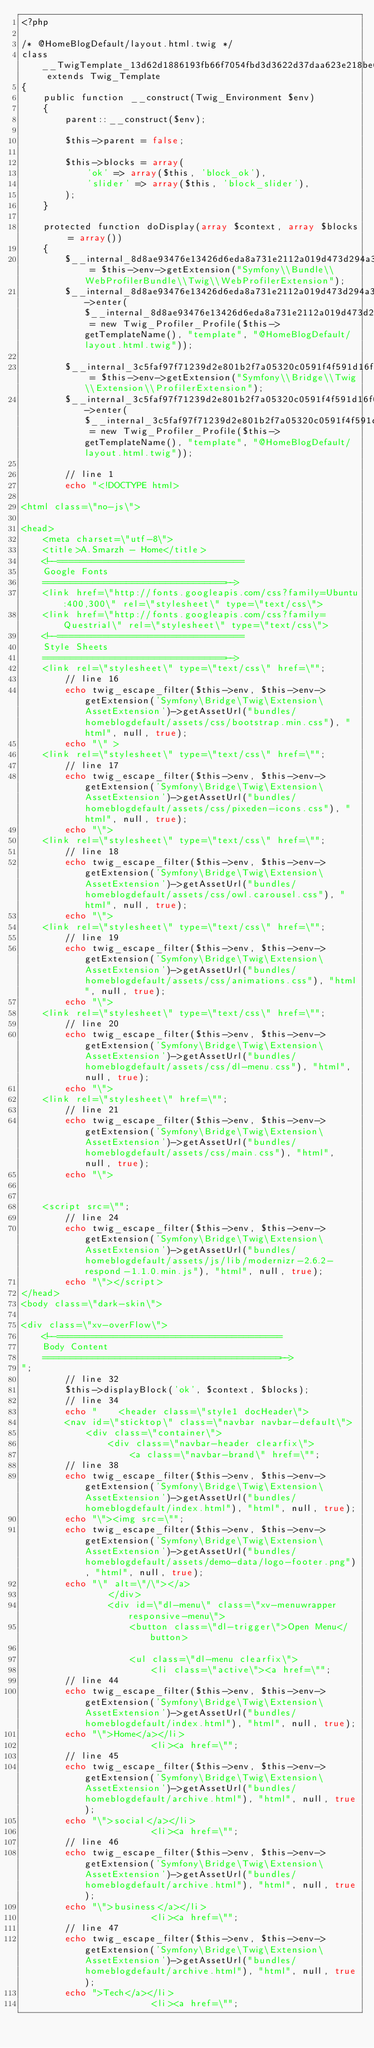Convert code to text. <code><loc_0><loc_0><loc_500><loc_500><_PHP_><?php

/* @HomeBlogDefault/layout.html.twig */
class __TwigTemplate_13d62d1886193fb66f7054fbd3d3622d37daa623e218be66a646269028b3d890 extends Twig_Template
{
    public function __construct(Twig_Environment $env)
    {
        parent::__construct($env);

        $this->parent = false;

        $this->blocks = array(
            'ok' => array($this, 'block_ok'),
            'slider' => array($this, 'block_slider'),
        );
    }

    protected function doDisplay(array $context, array $blocks = array())
    {
        $__internal_8d8ae93476e13426d6eda8a731e2112a019d473d294a39c8b48ecb1a699f4684 = $this->env->getExtension("Symfony\\Bundle\\WebProfilerBundle\\Twig\\WebProfilerExtension");
        $__internal_8d8ae93476e13426d6eda8a731e2112a019d473d294a39c8b48ecb1a699f4684->enter($__internal_8d8ae93476e13426d6eda8a731e2112a019d473d294a39c8b48ecb1a699f4684_prof = new Twig_Profiler_Profile($this->getTemplateName(), "template", "@HomeBlogDefault/layout.html.twig"));

        $__internal_3c5faf97f71239d2e801b2f7a05320c0591f4f591d16f0070a4f111e7c85e779 = $this->env->getExtension("Symfony\\Bridge\\Twig\\Extension\\ProfilerExtension");
        $__internal_3c5faf97f71239d2e801b2f7a05320c0591f4f591d16f0070a4f111e7c85e779->enter($__internal_3c5faf97f71239d2e801b2f7a05320c0591f4f591d16f0070a4f111e7c85e779_prof = new Twig_Profiler_Profile($this->getTemplateName(), "template", "@HomeBlogDefault/layout.html.twig"));

        // line 1
        echo "<!DOCTYPE html>

<html class=\"no-js\">

<head>
    <meta charset=\"utf-8\">
    <title>A.Smarzh - Home</title>
    <!--=================================
    Google Fonts
    =================================-->
    <link href=\"http://fonts.googleapis.com/css?family=Ubuntu:400,300\" rel=\"stylesheet\" type=\"text/css\">
    <link href=\"http://fonts.googleapis.com/css?family=Questrial\" rel=\"stylesheet\" type=\"text/css\">
    <!--=================================
    Style Sheets
    =================================-->
    <link rel=\"stylesheet\" type=\"text/css\" href=\"";
        // line 16
        echo twig_escape_filter($this->env, $this->env->getExtension('Symfony\Bridge\Twig\Extension\AssetExtension')->getAssetUrl("bundles/homeblogdefault/assets/css/bootstrap.min.css"), "html", null, true);
        echo "\" >
    <link rel=\"stylesheet\" type=\"text/css\" href=\"";
        // line 17
        echo twig_escape_filter($this->env, $this->env->getExtension('Symfony\Bridge\Twig\Extension\AssetExtension')->getAssetUrl("bundles/homeblogdefault/assets/css/pixeden-icons.css"), "html", null, true);
        echo "\">
    <link rel=\"stylesheet\" type=\"text/css\" href=\"";
        // line 18
        echo twig_escape_filter($this->env, $this->env->getExtension('Symfony\Bridge\Twig\Extension\AssetExtension')->getAssetUrl("bundles/homeblogdefault/assets/css/owl.carousel.css"), "html", null, true);
        echo "\">
    <link rel=\"stylesheet\" type=\"text/css\" href=\"";
        // line 19
        echo twig_escape_filter($this->env, $this->env->getExtension('Symfony\Bridge\Twig\Extension\AssetExtension')->getAssetUrl("bundles/homeblogdefault/assets/css/animations.css"), "html", null, true);
        echo "\">
    <link rel=\"stylesheet\" type=\"text/css\" href=\"";
        // line 20
        echo twig_escape_filter($this->env, $this->env->getExtension('Symfony\Bridge\Twig\Extension\AssetExtension')->getAssetUrl("bundles/homeblogdefault/assets/css/dl-menu.css"), "html", null, true);
        echo "\">
    <link rel=\"stylesheet\" href=\"";
        // line 21
        echo twig_escape_filter($this->env, $this->env->getExtension('Symfony\Bridge\Twig\Extension\AssetExtension')->getAssetUrl("bundles/homeblogdefault/assets/css/main.css"), "html", null, true);
        echo "\">


    <script src=\"";
        // line 24
        echo twig_escape_filter($this->env, $this->env->getExtension('Symfony\Bridge\Twig\Extension\AssetExtension')->getAssetUrl("bundles/homeblogdefault/assets/js/lib/modernizr-2.6.2-respond-1.1.0.min.js"), "html", null, true);
        echo "\"></script>
</head>
<body class=\"dark-skin\">

<div class=\"xv-overFlow\">
    <!--========================================
    Body Content
    ===========================================-->
";
        // line 32
        $this->displayBlock('ok', $context, $blocks);
        // line 34
        echo "    <header class=\"style1 docHeader\">
        <nav id=\"sticktop\" class=\"navbar navbar-default\">
            <div class=\"container\">
                <div class=\"navbar-header clearfix\">
                    <a class=\"navbar-brand\" href=\"";
        // line 38
        echo twig_escape_filter($this->env, $this->env->getExtension('Symfony\Bridge\Twig\Extension\AssetExtension')->getAssetUrl("bundles/homeblogdefault/index.html"), "html", null, true);
        echo "\"><img src=\"";
        echo twig_escape_filter($this->env, $this->env->getExtension('Symfony\Bridge\Twig\Extension\AssetExtension')->getAssetUrl("bundles/homeblogdefault/assets/demo-data/logo-footer.png"), "html", null, true);
        echo "\" alt=\"/\"></a>
                </div>
                <div id=\"dl-menu\" class=\"xv-menuwrapper responsive-menu\">
                    <button class=\"dl-trigger\">Open Menu</button>

                    <ul class=\"dl-menu clearfix\">
                        <li class=\"active\"><a href=\"";
        // line 44
        echo twig_escape_filter($this->env, $this->env->getExtension('Symfony\Bridge\Twig\Extension\AssetExtension')->getAssetUrl("bundles/homeblogdefault/index.html"), "html", null, true);
        echo "\">Home</a></li>
                        <li><a href=\"";
        // line 45
        echo twig_escape_filter($this->env, $this->env->getExtension('Symfony\Bridge\Twig\Extension\AssetExtension')->getAssetUrl("bundles/homeblogdefault/archive.html"), "html", null, true);
        echo "\">social</a></li>
                        <li><a href=\"";
        // line 46
        echo twig_escape_filter($this->env, $this->env->getExtension('Symfony\Bridge\Twig\Extension\AssetExtension')->getAssetUrl("bundles/homeblogdefault/archive.html"), "html", null, true);
        echo "\">business</a></li>
                        <li><a href=\"";
        // line 47
        echo twig_escape_filter($this->env, $this->env->getExtension('Symfony\Bridge\Twig\Extension\AssetExtension')->getAssetUrl("bundles/homeblogdefault/archive.html"), "html", null, true);
        echo ">Tech</a></li>
                        <li><a href=\"";</code> 